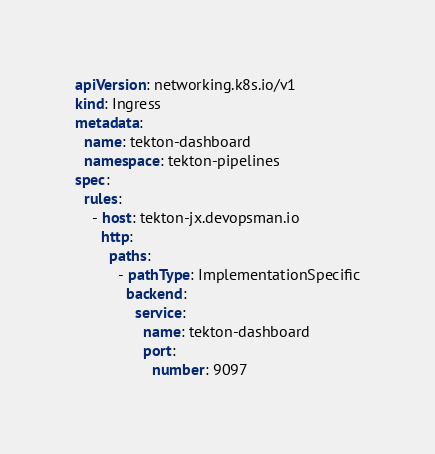Convert code to text. <code><loc_0><loc_0><loc_500><loc_500><_YAML_>apiVersion: networking.k8s.io/v1
kind: Ingress
metadata:
  name: tekton-dashboard
  namespace: tekton-pipelines
spec:
  rules:
    - host: tekton-jx.devopsman.io
      http:
        paths:
          - pathType: ImplementationSpecific
            backend:
              service:
                name: tekton-dashboard
                port:
                  number: 9097
</code> 